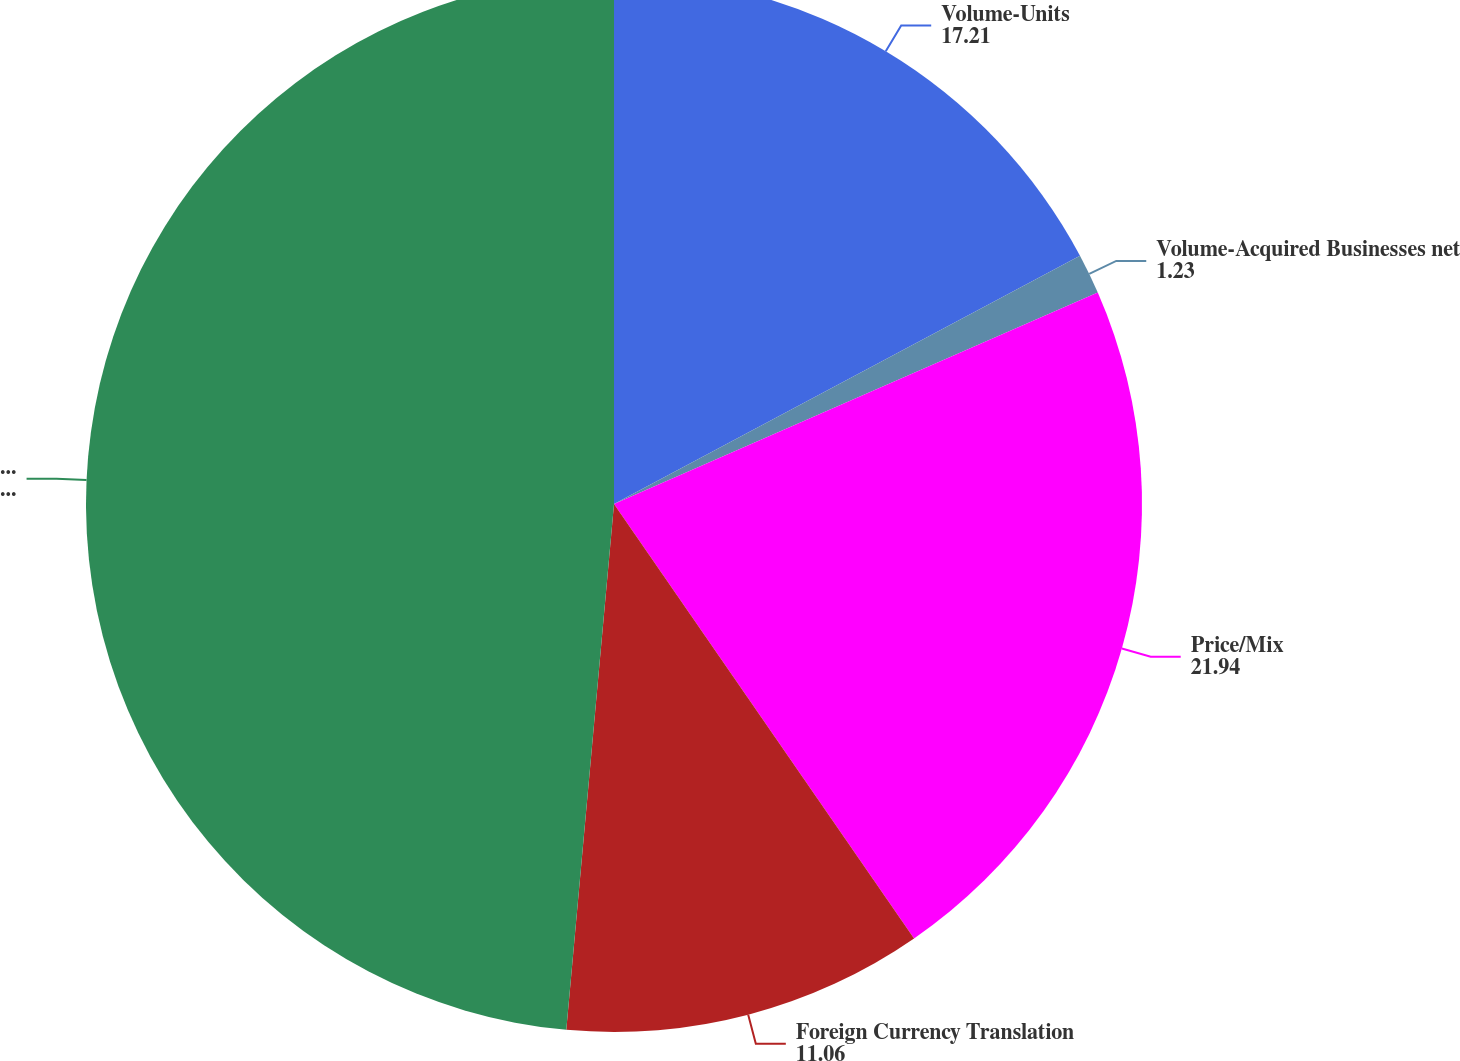Convert chart to OTSL. <chart><loc_0><loc_0><loc_500><loc_500><pie_chart><fcel>Volume-Units<fcel>Volume-Acquired Businesses net<fcel>Price/Mix<fcel>Foreign Currency Translation<fcel>Total<nl><fcel>17.21%<fcel>1.23%<fcel>21.94%<fcel>11.06%<fcel>48.56%<nl></chart> 